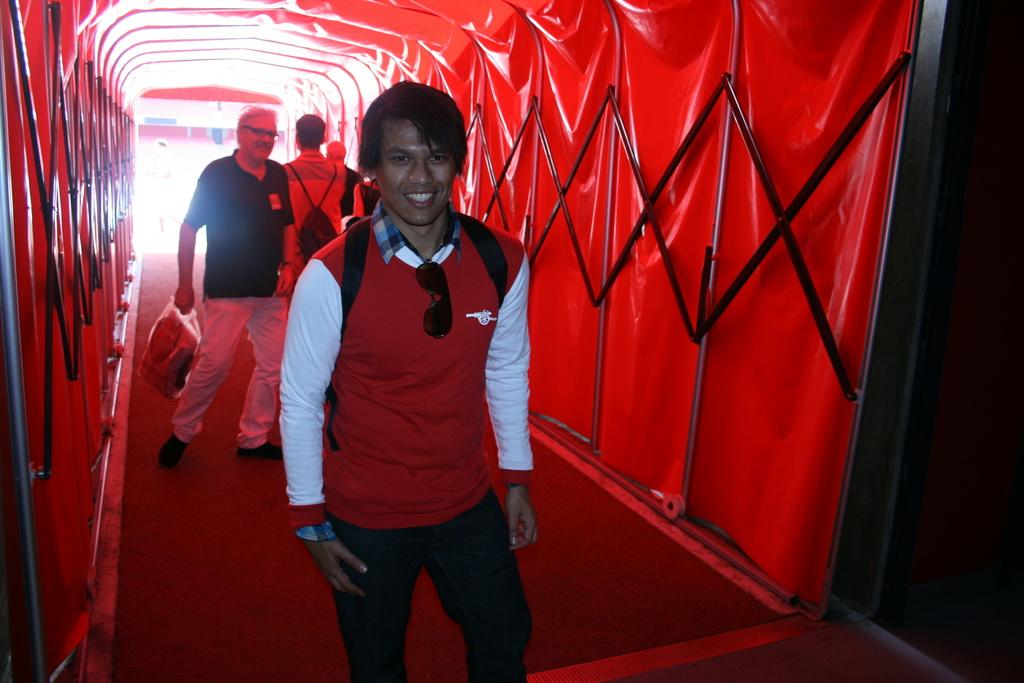How many people are in the image? There is a group of people in the image, but the exact number is not specified. Where are the people located in the image? The people are on a walkway. What can be seen on the sides of the walkway? There are iron grilles on the left and right sides of the people. What is associated with the iron grilles? There is an object associated with the iron grilles, but the specific object is not mentioned. What type of cracker is being eaten by the spiders on the walkway in the image? There are no spiders or crackers present in the image. 